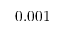<formula> <loc_0><loc_0><loc_500><loc_500>0 . 0 0 1</formula> 